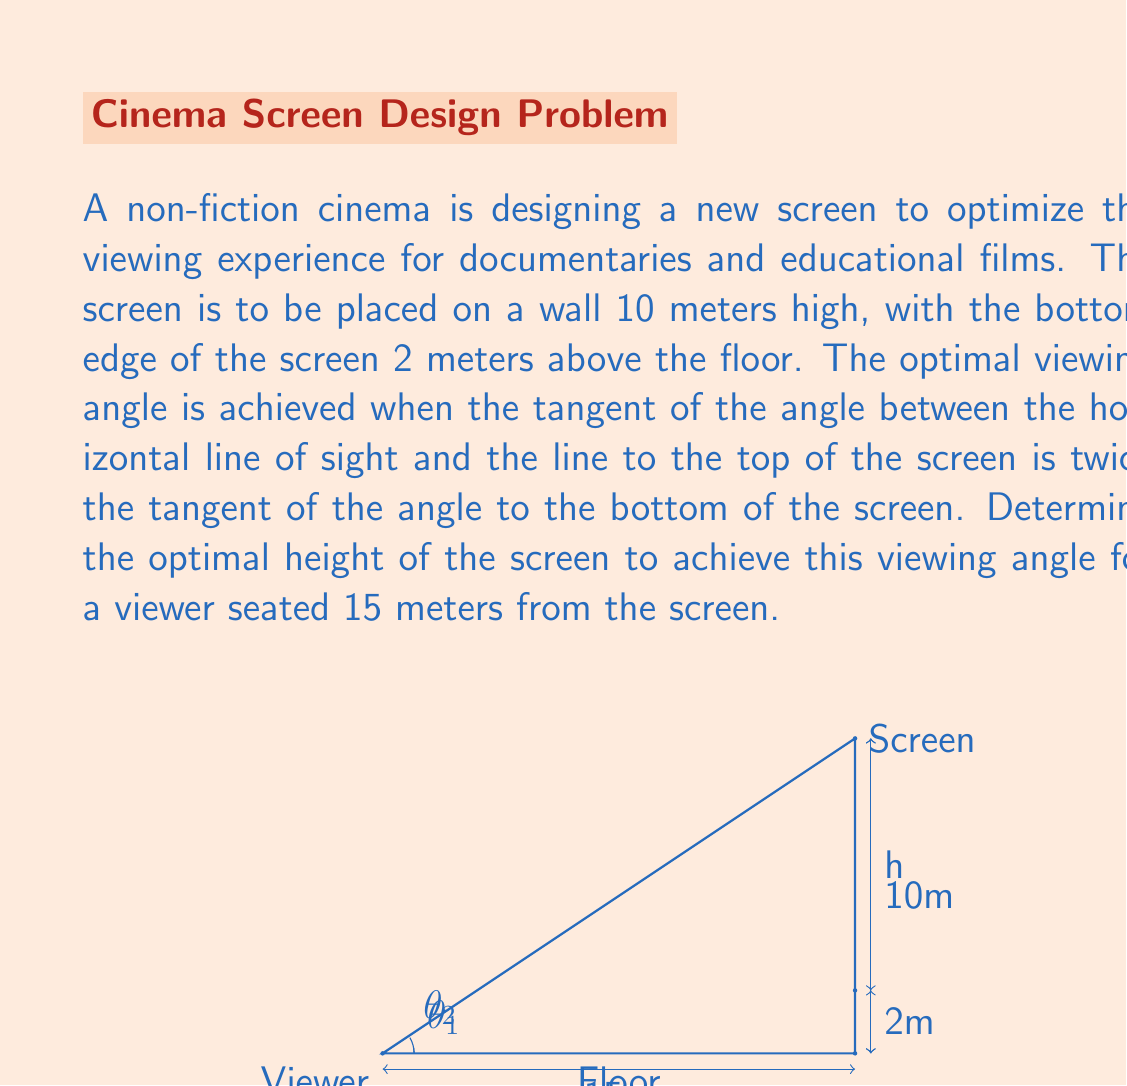Solve this math problem. Let's approach this step-by-step:

1) Let $h$ be the height of the screen. The bottom of the screen is 2 meters above the floor, so the top of the screen is at $(2+h)$ meters.

2) Let $\theta_1$ be the angle to the bottom of the screen and $\theta_2$ be the angle to the top of the screen.

3) From the given conditions:

   $\tan(\theta_2) = 2\tan(\theta_1)$

4) We can express these tangents in terms of $h$:

   $\tan(\theta_1) = \frac{2}{15}$
   $\tan(\theta_2) = \frac{2+h}{15}$

5) Substituting into the condition:

   $\frac{2+h}{15} = 2(\frac{2}{15})$

6) Simplify:

   $2+h = 4$

7) Solve for $h$:

   $h = 4 - 2 = 2$

Therefore, the optimal height of the screen is 2 meters.

8) To verify, let's check the tangent condition:

   $\tan(\theta_2) = \frac{2+2}{15} = \frac{4}{15}$
   $\tan(\theta_1) = \frac{2}{15}$

   Indeed, $\frac{4}{15} = 2(\frac{2}{15})$, so our solution satisfies the condition.
Answer: 2 meters 